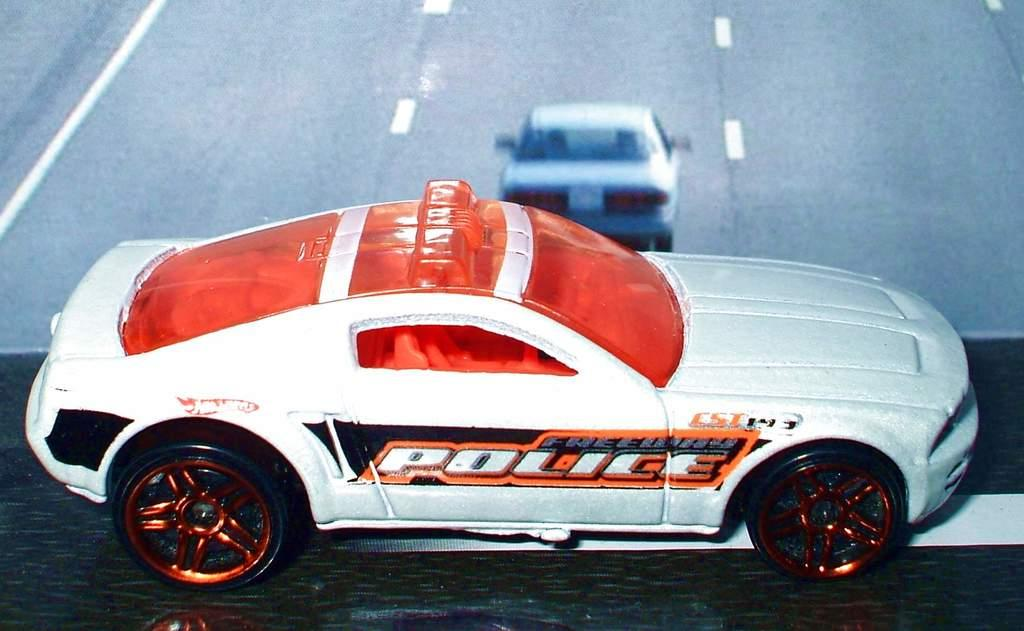What is the main object in the image? There is a toy car in the image. Where is the toy car located? The toy car is placed on a table. Can you describe any other objects or features in the image? There might be a television screen in the image, and if so, it displays a car running on a road. What type of scarecrow is standing next to the toy car in the image? There is no scarecrow present in the image; it features a toy car on a table and possibly a television screen. How many marbles are visible in the image? There are no marbles visible in the image. 